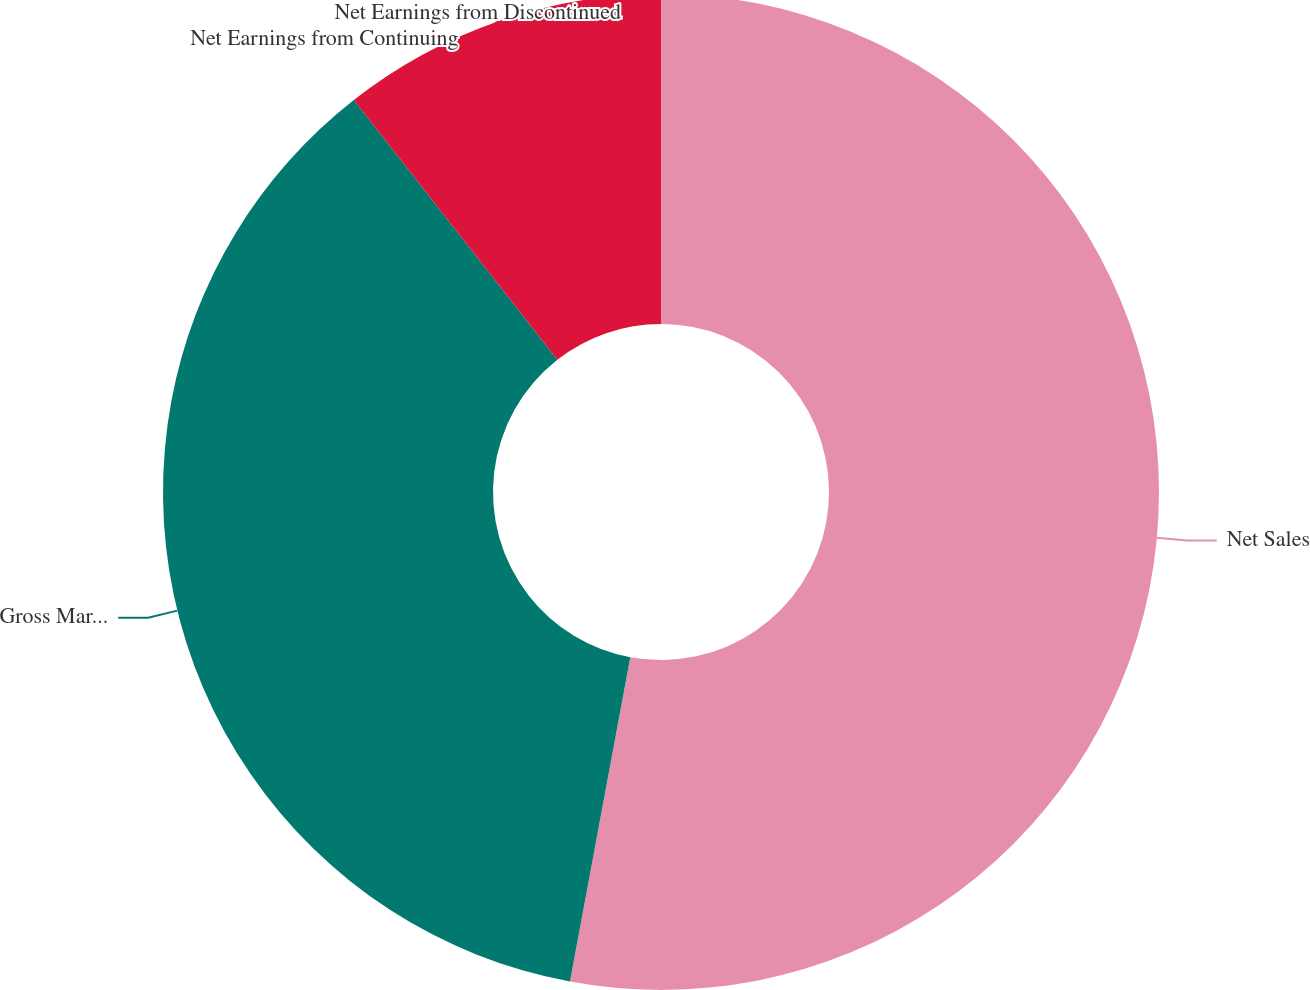Convert chart. <chart><loc_0><loc_0><loc_500><loc_500><pie_chart><fcel>Net Sales<fcel>Gross Margin<fcel>Net Earnings from Continuing<fcel>Net Earnings from Discontinued<nl><fcel>52.92%<fcel>36.49%<fcel>10.58%<fcel>0.0%<nl></chart> 